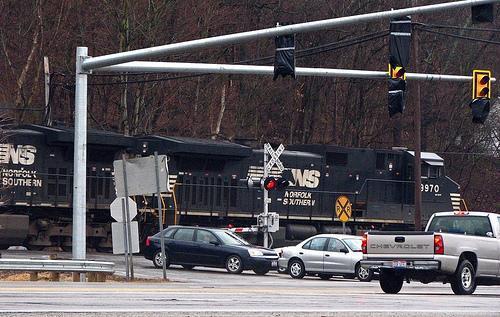How many cars are there?
Give a very brief answer. 3. How many cars are in the photo?
Give a very brief answer. 2. How many elephants are pictured?
Give a very brief answer. 0. 